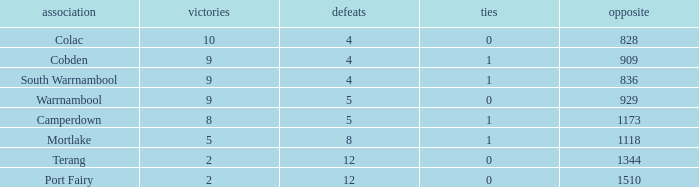What is the average number of draws for losses over 8 and Against values under 1344? None. 